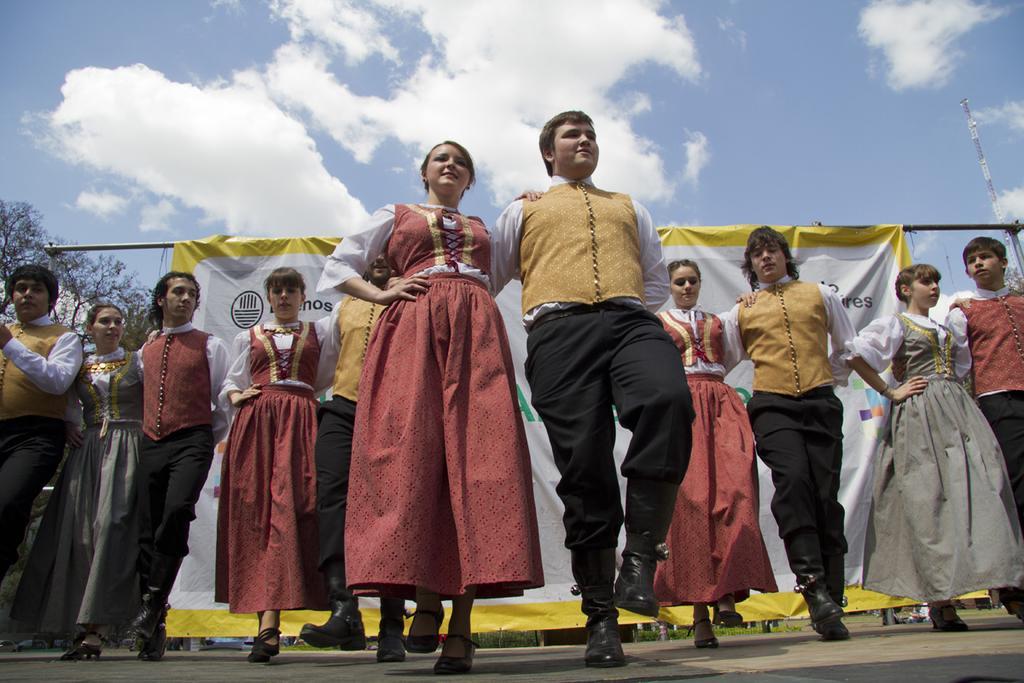How would you summarize this image in a sentence or two? In this image there are pairs of men and women in dancing position on the ground. In the background there is a banner to the rod. At the top there is a sky with clouds. Tower and tree is also is also visible. 